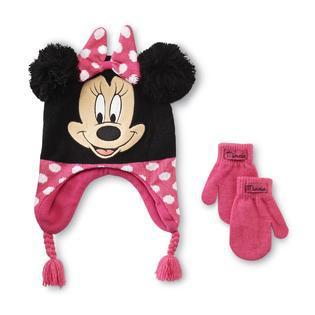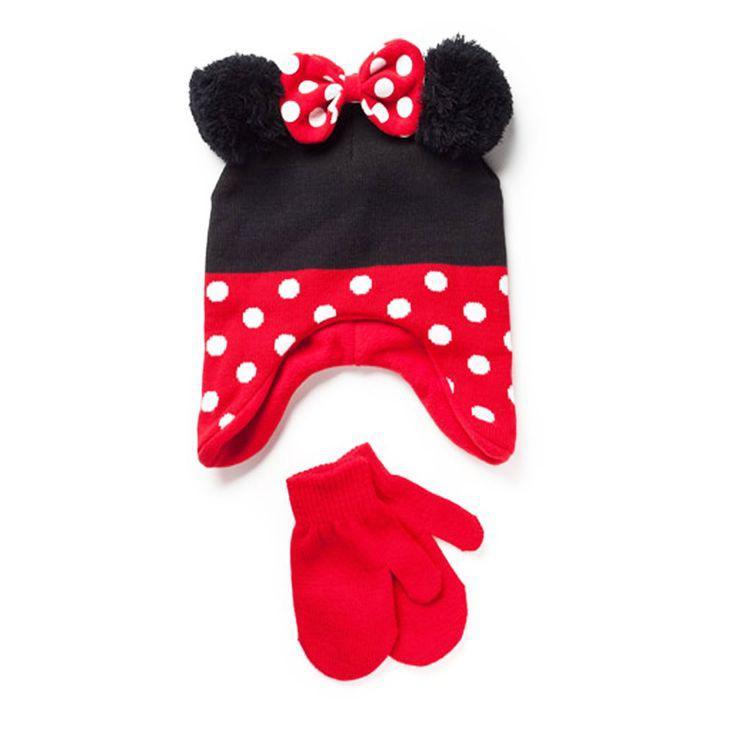The first image is the image on the left, the second image is the image on the right. Assess this claim about the two images: "Both images in the pair show a winter hat and mittens which are Micky Mouse or Minnie Mouse themed.". Correct or not? Answer yes or no. Yes. The first image is the image on the left, the second image is the image on the right. Evaluate the accuracy of this statement regarding the images: "The left image includes mittens next to a cap with black ears and pink polka dotted bow, and the right image shows mittens by a cap with black ears and white dots on red.". Is it true? Answer yes or no. Yes. 